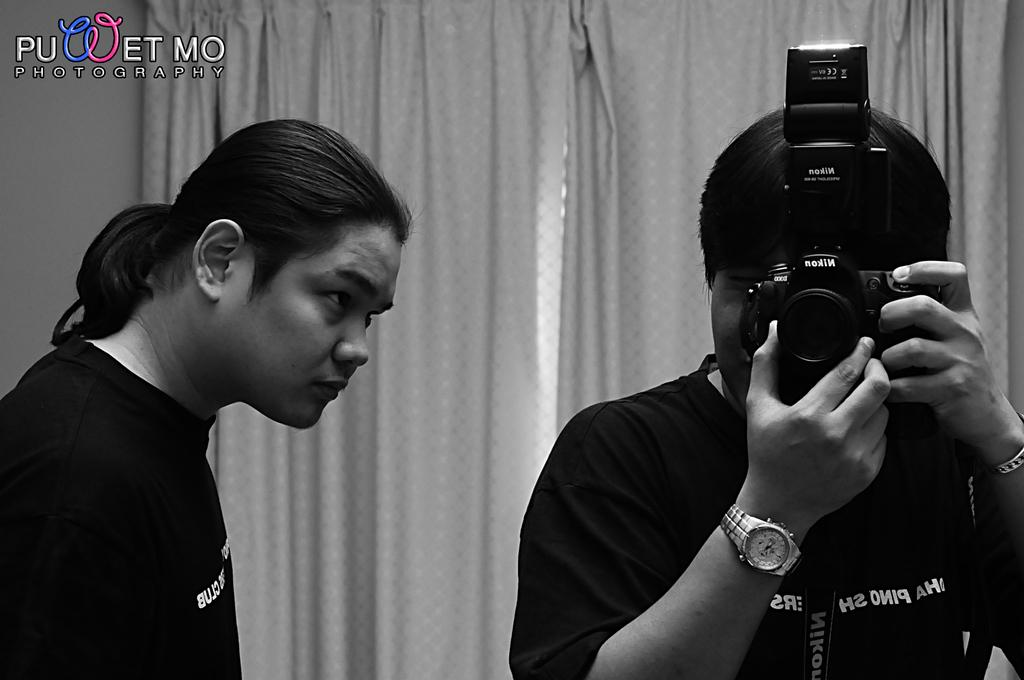How many people are in the image? There are two people in the image. What is one of the people doing in the image? One person is holding a camera. What else can be seen in the person's hand besides the camera? The person holding the camera has a watch in his hand. What can be seen in the background of the image? There are curtains in the background of the image. What type of insect can be seen crawling on the camera in the image? There is no insect visible on the camera in the image. What is the friction between the camera and the person's hand in the image? The provided facts do not mention any friction between the camera and the person's hand, so it cannot be determined from the image. 